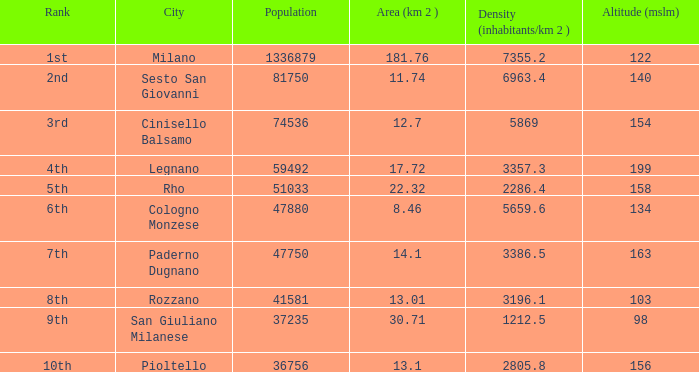8, a ranking of 1st, and an elevation (mslm) below 122? None. 